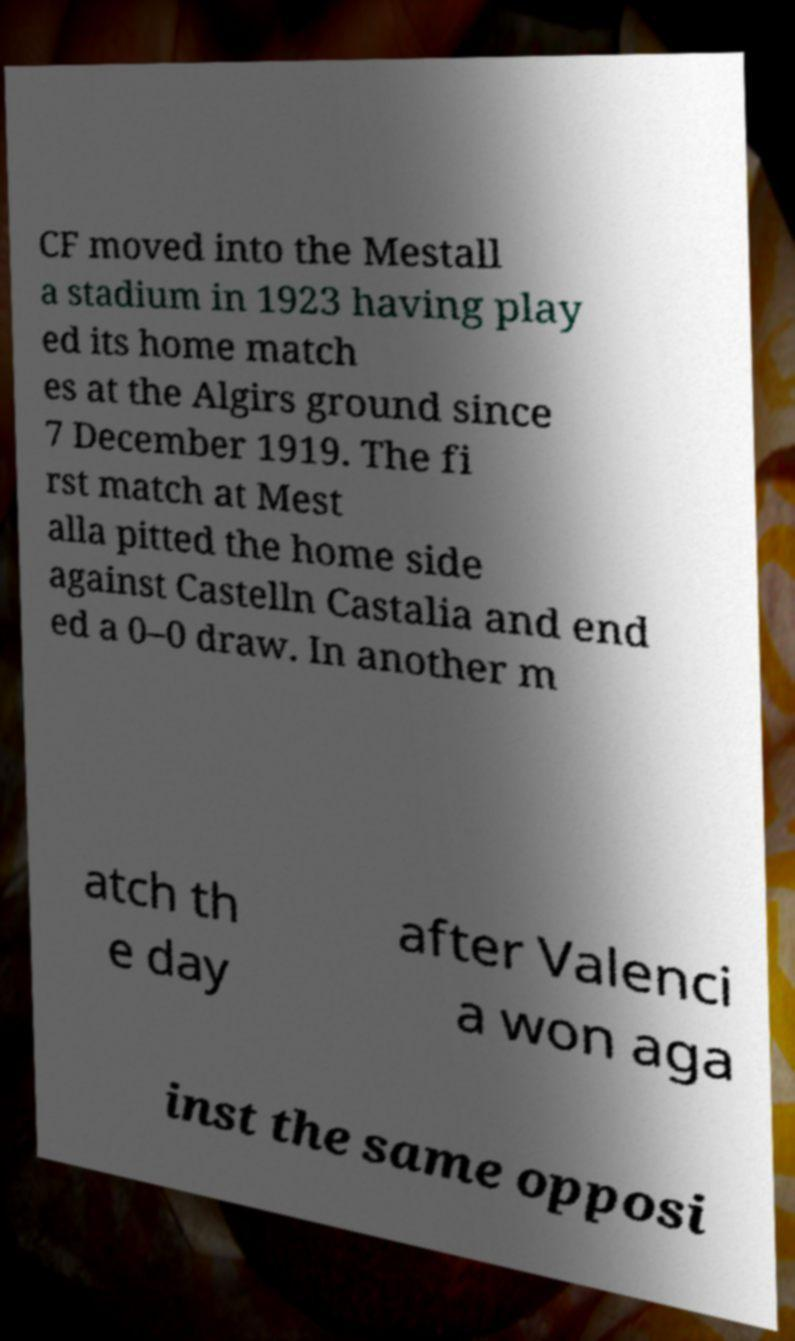What messages or text are displayed in this image? I need them in a readable, typed format. CF moved into the Mestall a stadium in 1923 having play ed its home match es at the Algirs ground since 7 December 1919. The fi rst match at Mest alla pitted the home side against Castelln Castalia and end ed a 0–0 draw. In another m atch th e day after Valenci a won aga inst the same opposi 